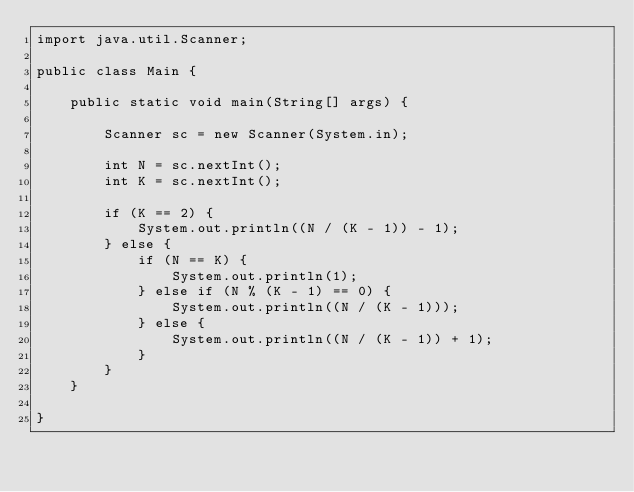<code> <loc_0><loc_0><loc_500><loc_500><_Java_>import java.util.Scanner;

public class Main {

	public static void main(String[] args) {

		Scanner sc = new Scanner(System.in);

		int N = sc.nextInt();
		int K = sc.nextInt();

		if (K == 2) {
			System.out.println((N / (K - 1)) - 1);
		} else {
			if (N == K) {
				System.out.println(1);
			} else if (N % (K - 1) == 0) {
				System.out.println((N / (K - 1)));
			} else {
				System.out.println((N / (K - 1)) + 1);
			}
		}
	}

}
</code> 